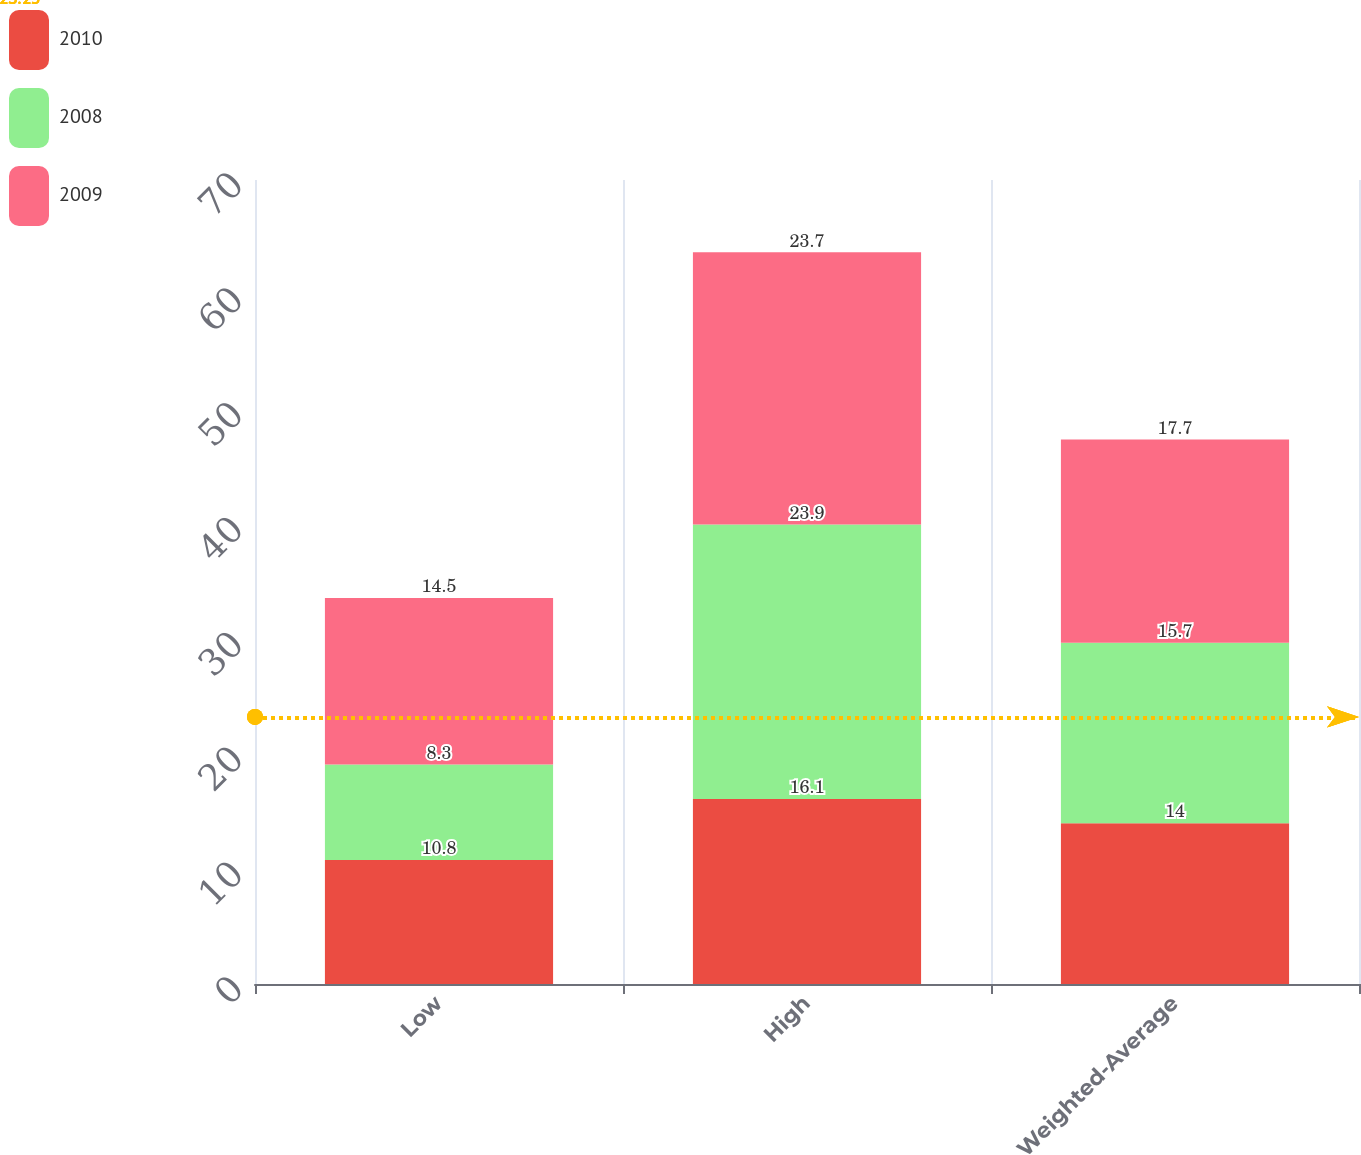Convert chart. <chart><loc_0><loc_0><loc_500><loc_500><stacked_bar_chart><ecel><fcel>Low<fcel>High<fcel>Weighted-Average<nl><fcel>2010<fcel>10.8<fcel>16.1<fcel>14<nl><fcel>2008<fcel>8.3<fcel>23.9<fcel>15.7<nl><fcel>2009<fcel>14.5<fcel>23.7<fcel>17.7<nl></chart> 